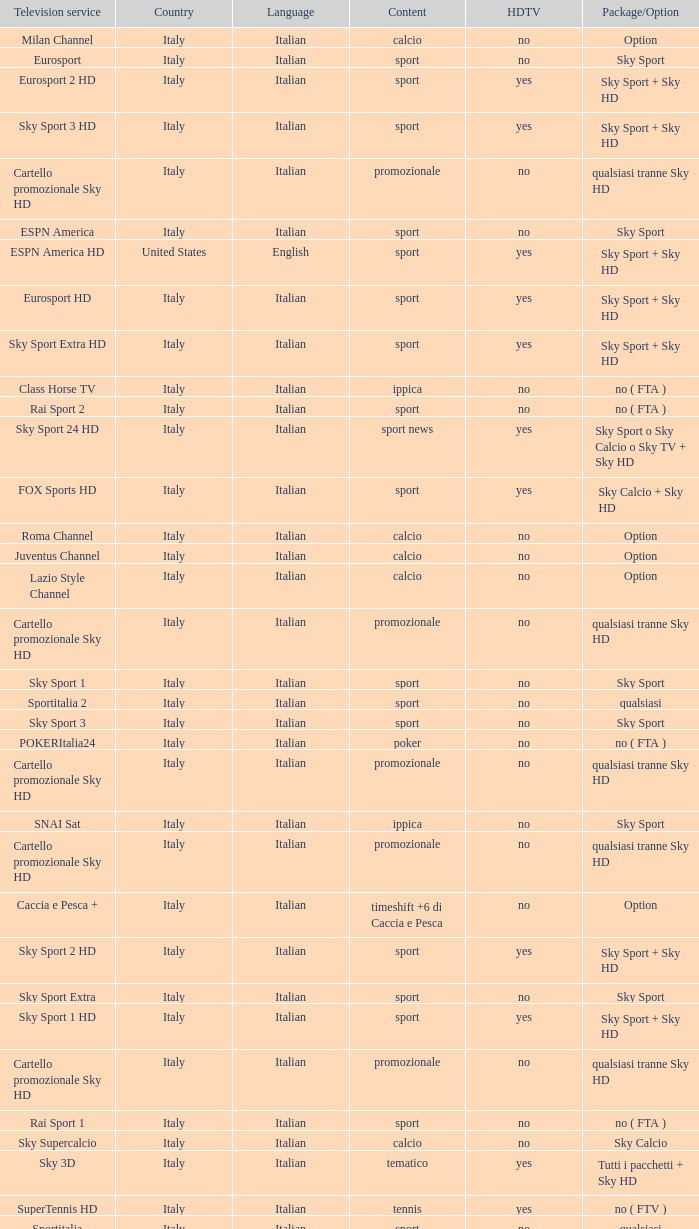What is Television Service, when Content is Calcio, and when Package/Option is Option? Milan Channel, Juventus Channel, Inter Channel, Lazio Style Channel, Roma Channel. 